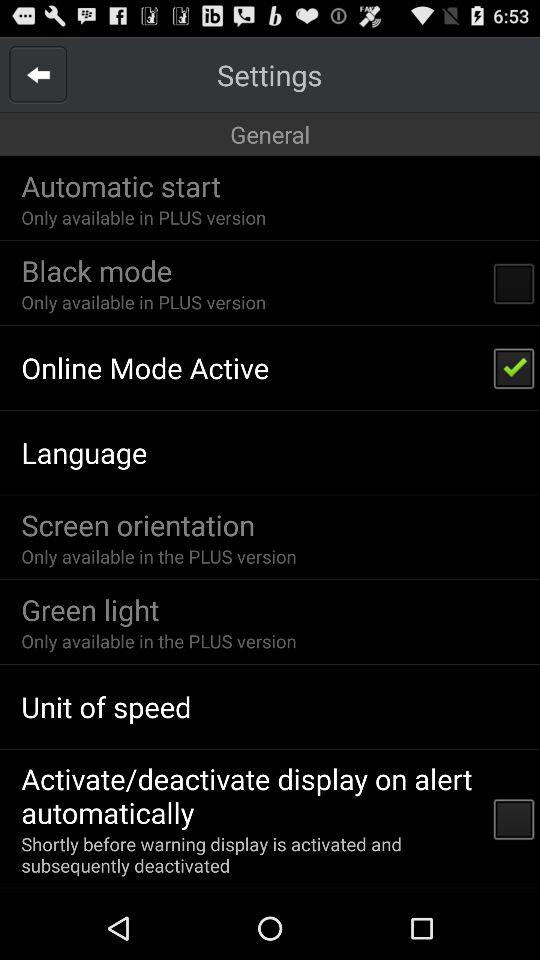How many of the options are only available in the PLUS version?
Answer the question using a single word or phrase. 4 